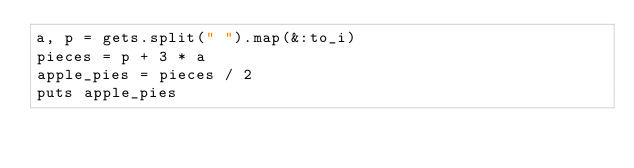Convert code to text. <code><loc_0><loc_0><loc_500><loc_500><_Ruby_>a, p = gets.split(" ").map(&:to_i)
pieces = p + 3 * a
apple_pies = pieces / 2
puts apple_pies</code> 